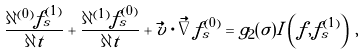<formula> <loc_0><loc_0><loc_500><loc_500>\frac { \partial ^ { ( 0 ) } f _ { s } ^ { ( 1 ) } } { \partial t } + \frac { \partial ^ { ( 1 ) } f _ { s } ^ { ( 0 ) } } { \partial t } + \vec { v } \cdot \vec { \nabla } f _ { s } ^ { ( 0 ) } = g _ { 2 } ( \sigma ) I \left ( f , f _ { s } ^ { ( 1 ) } \right ) \, ,</formula> 